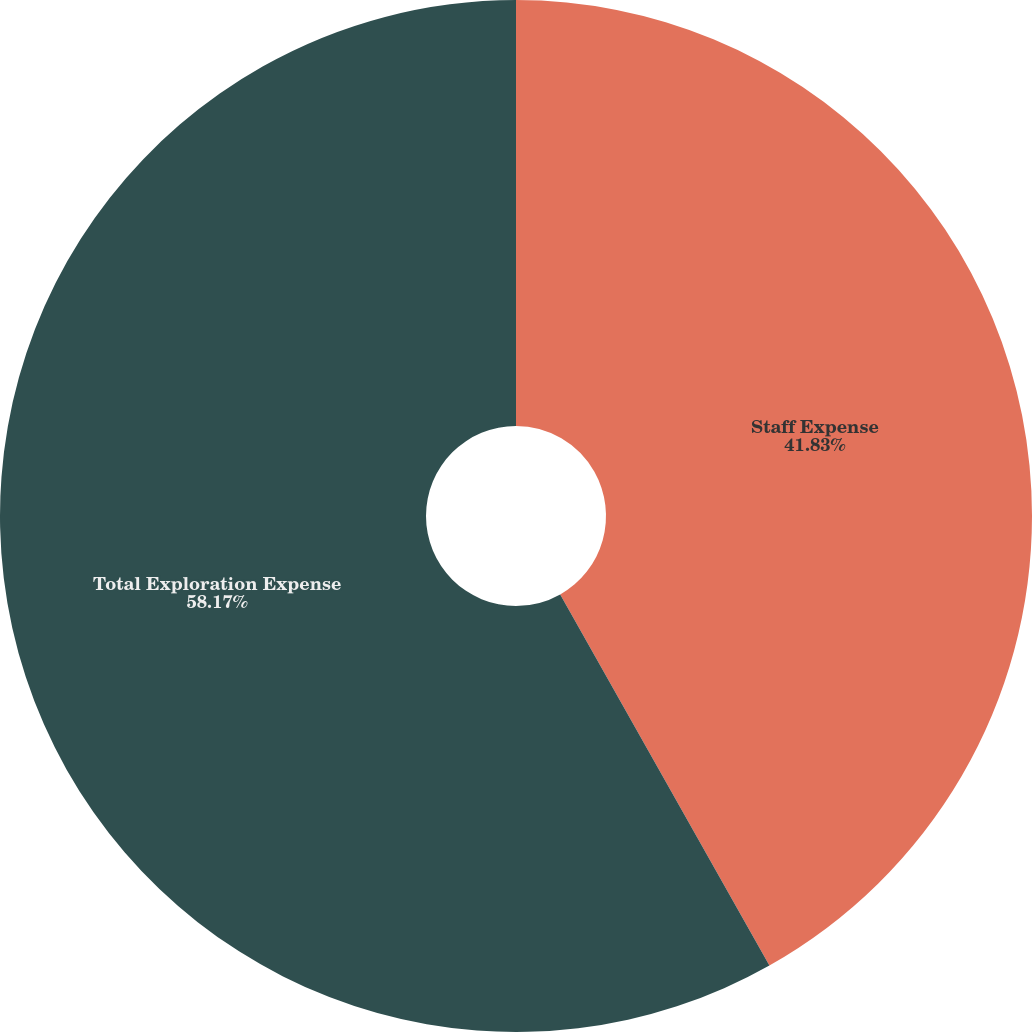Convert chart to OTSL. <chart><loc_0><loc_0><loc_500><loc_500><pie_chart><fcel>Staff Expense<fcel>Total Exploration Expense<nl><fcel>41.83%<fcel>58.17%<nl></chart> 